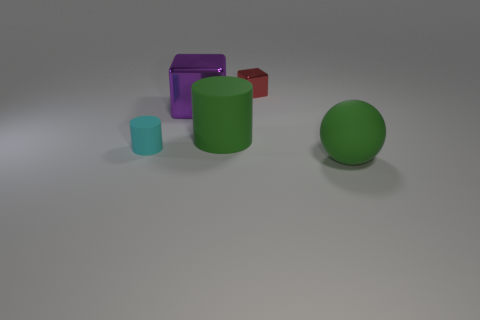What is the shape of the object that is the same color as the big ball?
Ensure brevity in your answer.  Cylinder. How many other objects are there of the same size as the red metal object?
Your response must be concise. 1. What size is the green object that is in front of the green rubber thing left of the tiny red metallic block?
Give a very brief answer. Large. What color is the large rubber thing on the left side of the green thing that is in front of the matte cylinder that is right of the purple metal block?
Your response must be concise. Green. How big is the object that is behind the green rubber cylinder and in front of the tiny metallic object?
Give a very brief answer. Large. How many other objects are the same shape as the cyan thing?
Give a very brief answer. 1. What number of cylinders are either tiny red metal things or matte things?
Your answer should be compact. 2. Is there a large matte cylinder left of the big green rubber thing that is on the left side of the big green matte thing that is right of the red thing?
Ensure brevity in your answer.  No. What color is the other object that is the same shape as the tiny matte thing?
Make the answer very short. Green. What number of purple things are either large rubber things or big metallic cubes?
Your response must be concise. 1. 